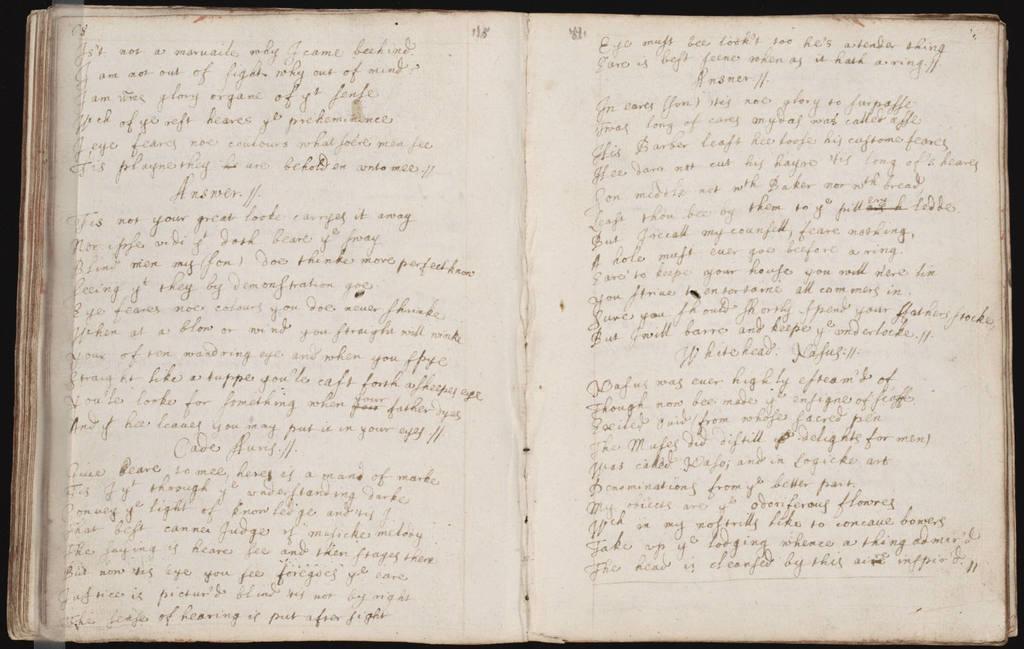Can you describe this image briefly? In this image there is some text on the pages of a book. 